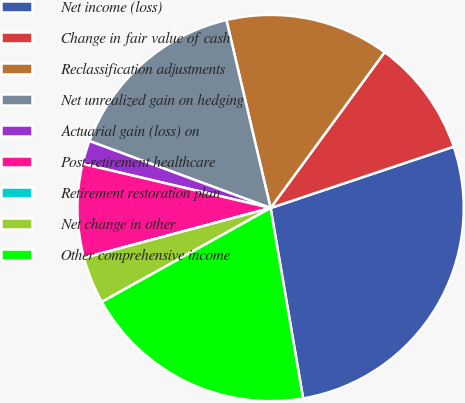Convert chart to OTSL. <chart><loc_0><loc_0><loc_500><loc_500><pie_chart><fcel>Net income (loss)<fcel>Change in fair value of cash<fcel>Reclassification adjustments<fcel>Net unrealized gain on hedging<fcel>Actuarial gain (loss) on<fcel>Post-retirement healthcare<fcel>Retirement restoration plan<fcel>Net change in other<fcel>Other comprehensive income<nl><fcel>27.45%<fcel>9.8%<fcel>13.73%<fcel>15.69%<fcel>1.96%<fcel>7.84%<fcel>0.0%<fcel>3.92%<fcel>19.61%<nl></chart> 